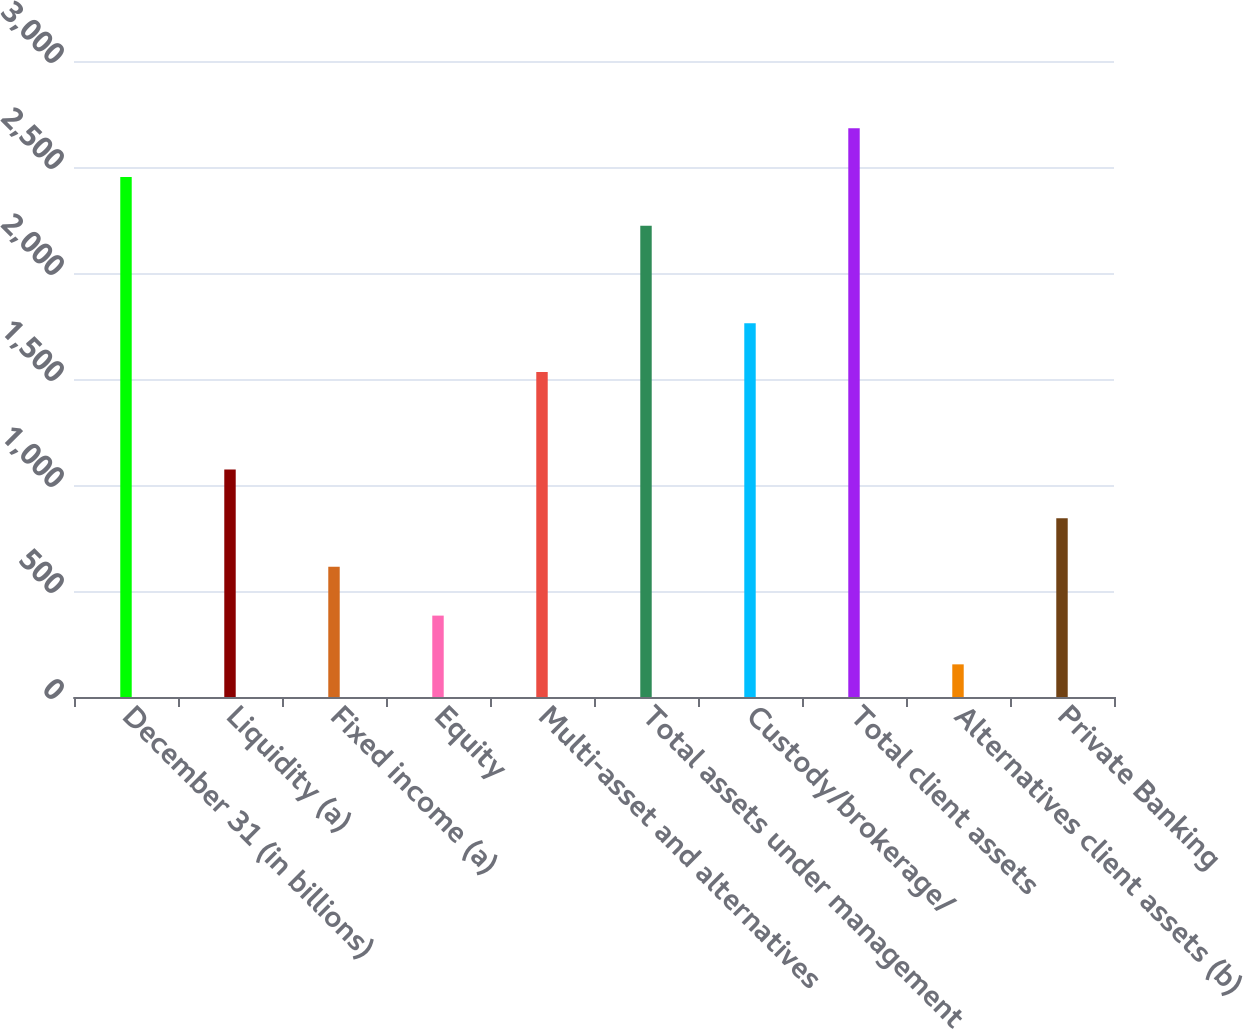Convert chart to OTSL. <chart><loc_0><loc_0><loc_500><loc_500><bar_chart><fcel>December 31 (in billions)<fcel>Liquidity (a)<fcel>Fixed income (a)<fcel>Equity<fcel>Multi-asset and alternatives<fcel>Total assets under management<fcel>Custody/brokerage/<fcel>Total client assets<fcel>Alternatives client assets (b)<fcel>Private Banking<nl><fcel>2453<fcel>1073.6<fcel>613.8<fcel>383.9<fcel>1533.4<fcel>2223.1<fcel>1763.3<fcel>2682.9<fcel>154<fcel>843.7<nl></chart> 